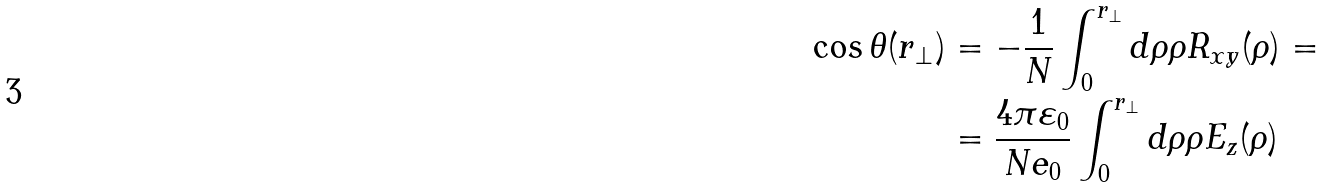Convert formula to latex. <formula><loc_0><loc_0><loc_500><loc_500>\cos \theta ( r _ { \perp } ) & = - \frac { 1 } { N } \int _ { 0 } ^ { r _ { \perp } } d \rho \rho R _ { x y } ( \rho ) = \\ & = \frac { 4 \pi \varepsilon _ { 0 } } { N e _ { 0 } } \int _ { 0 } ^ { r _ { \perp } } d \rho \rho E _ { z } ( \rho )</formula> 